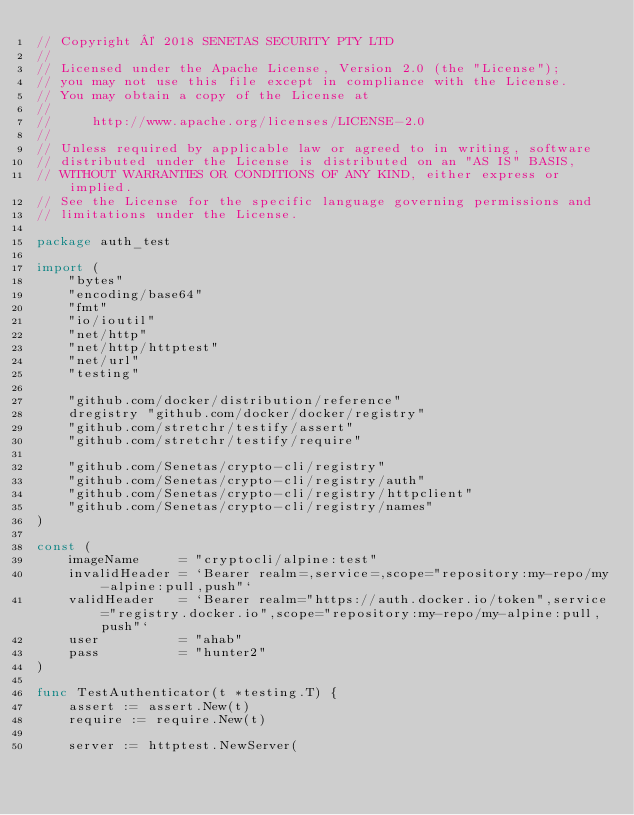<code> <loc_0><loc_0><loc_500><loc_500><_Go_>// Copyright © 2018 SENETAS SECURITY PTY LTD
//
// Licensed under the Apache License, Version 2.0 (the "License");
// you may not use this file except in compliance with the License.
// You may obtain a copy of the License at
//
//     http://www.apache.org/licenses/LICENSE-2.0
//
// Unless required by applicable law or agreed to in writing, software
// distributed under the License is distributed on an "AS IS" BASIS,
// WITHOUT WARRANTIES OR CONDITIONS OF ANY KIND, either express or implied.
// See the License for the specific language governing permissions and
// limitations under the License.

package auth_test

import (
	"bytes"
	"encoding/base64"
	"fmt"
	"io/ioutil"
	"net/http"
	"net/http/httptest"
	"net/url"
	"testing"

	"github.com/docker/distribution/reference"
	dregistry "github.com/docker/docker/registry"
	"github.com/stretchr/testify/assert"
	"github.com/stretchr/testify/require"

	"github.com/Senetas/crypto-cli/registry"
	"github.com/Senetas/crypto-cli/registry/auth"
	"github.com/Senetas/crypto-cli/registry/httpclient"
	"github.com/Senetas/crypto-cli/registry/names"
)

const (
	imageName     = "cryptocli/alpine:test"
	invalidHeader = `Bearer realm=,service=,scope="repository:my-repo/my-alpine:pull,push"`
	validHeader   = `Bearer realm="https://auth.docker.io/token",service="registry.docker.io",scope="repository:my-repo/my-alpine:pull,push"`
	user          = "ahab"
	pass          = "hunter2"
)

func TestAuthenticator(t *testing.T) {
	assert := assert.New(t)
	require := require.New(t)

	server := httptest.NewServer(</code> 